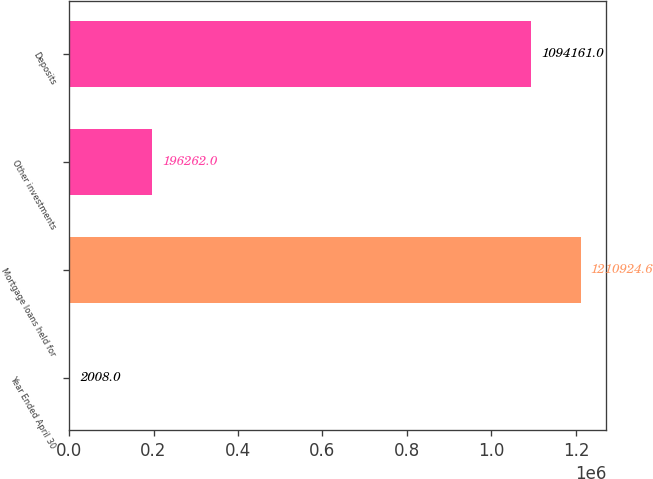Convert chart to OTSL. <chart><loc_0><loc_0><loc_500><loc_500><bar_chart><fcel>Year Ended April 30<fcel>Mortgage loans held for<fcel>Other investments<fcel>Deposits<nl><fcel>2008<fcel>1.21092e+06<fcel>196262<fcel>1.09416e+06<nl></chart> 